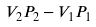Convert formula to latex. <formula><loc_0><loc_0><loc_500><loc_500>V _ { 2 } P _ { 2 } - V _ { 1 } P _ { 1 }</formula> 